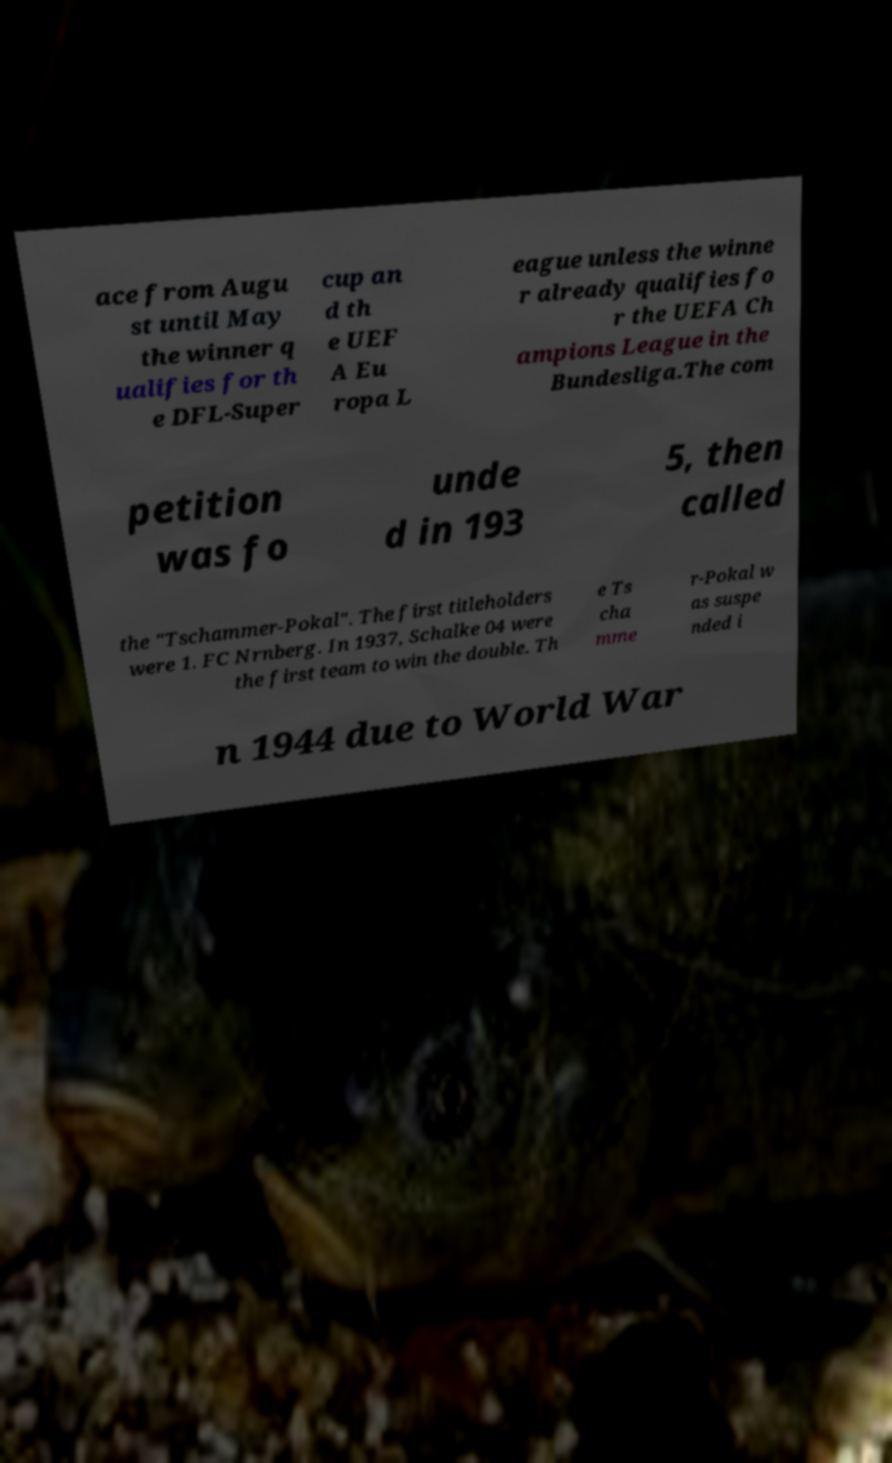Please identify and transcribe the text found in this image. ace from Augu st until May the winner q ualifies for th e DFL-Super cup an d th e UEF A Eu ropa L eague unless the winne r already qualifies fo r the UEFA Ch ampions League in the Bundesliga.The com petition was fo unde d in 193 5, then called the "Tschammer-Pokal". The first titleholders were 1. FC Nrnberg. In 1937, Schalke 04 were the first team to win the double. Th e Ts cha mme r-Pokal w as suspe nded i n 1944 due to World War 